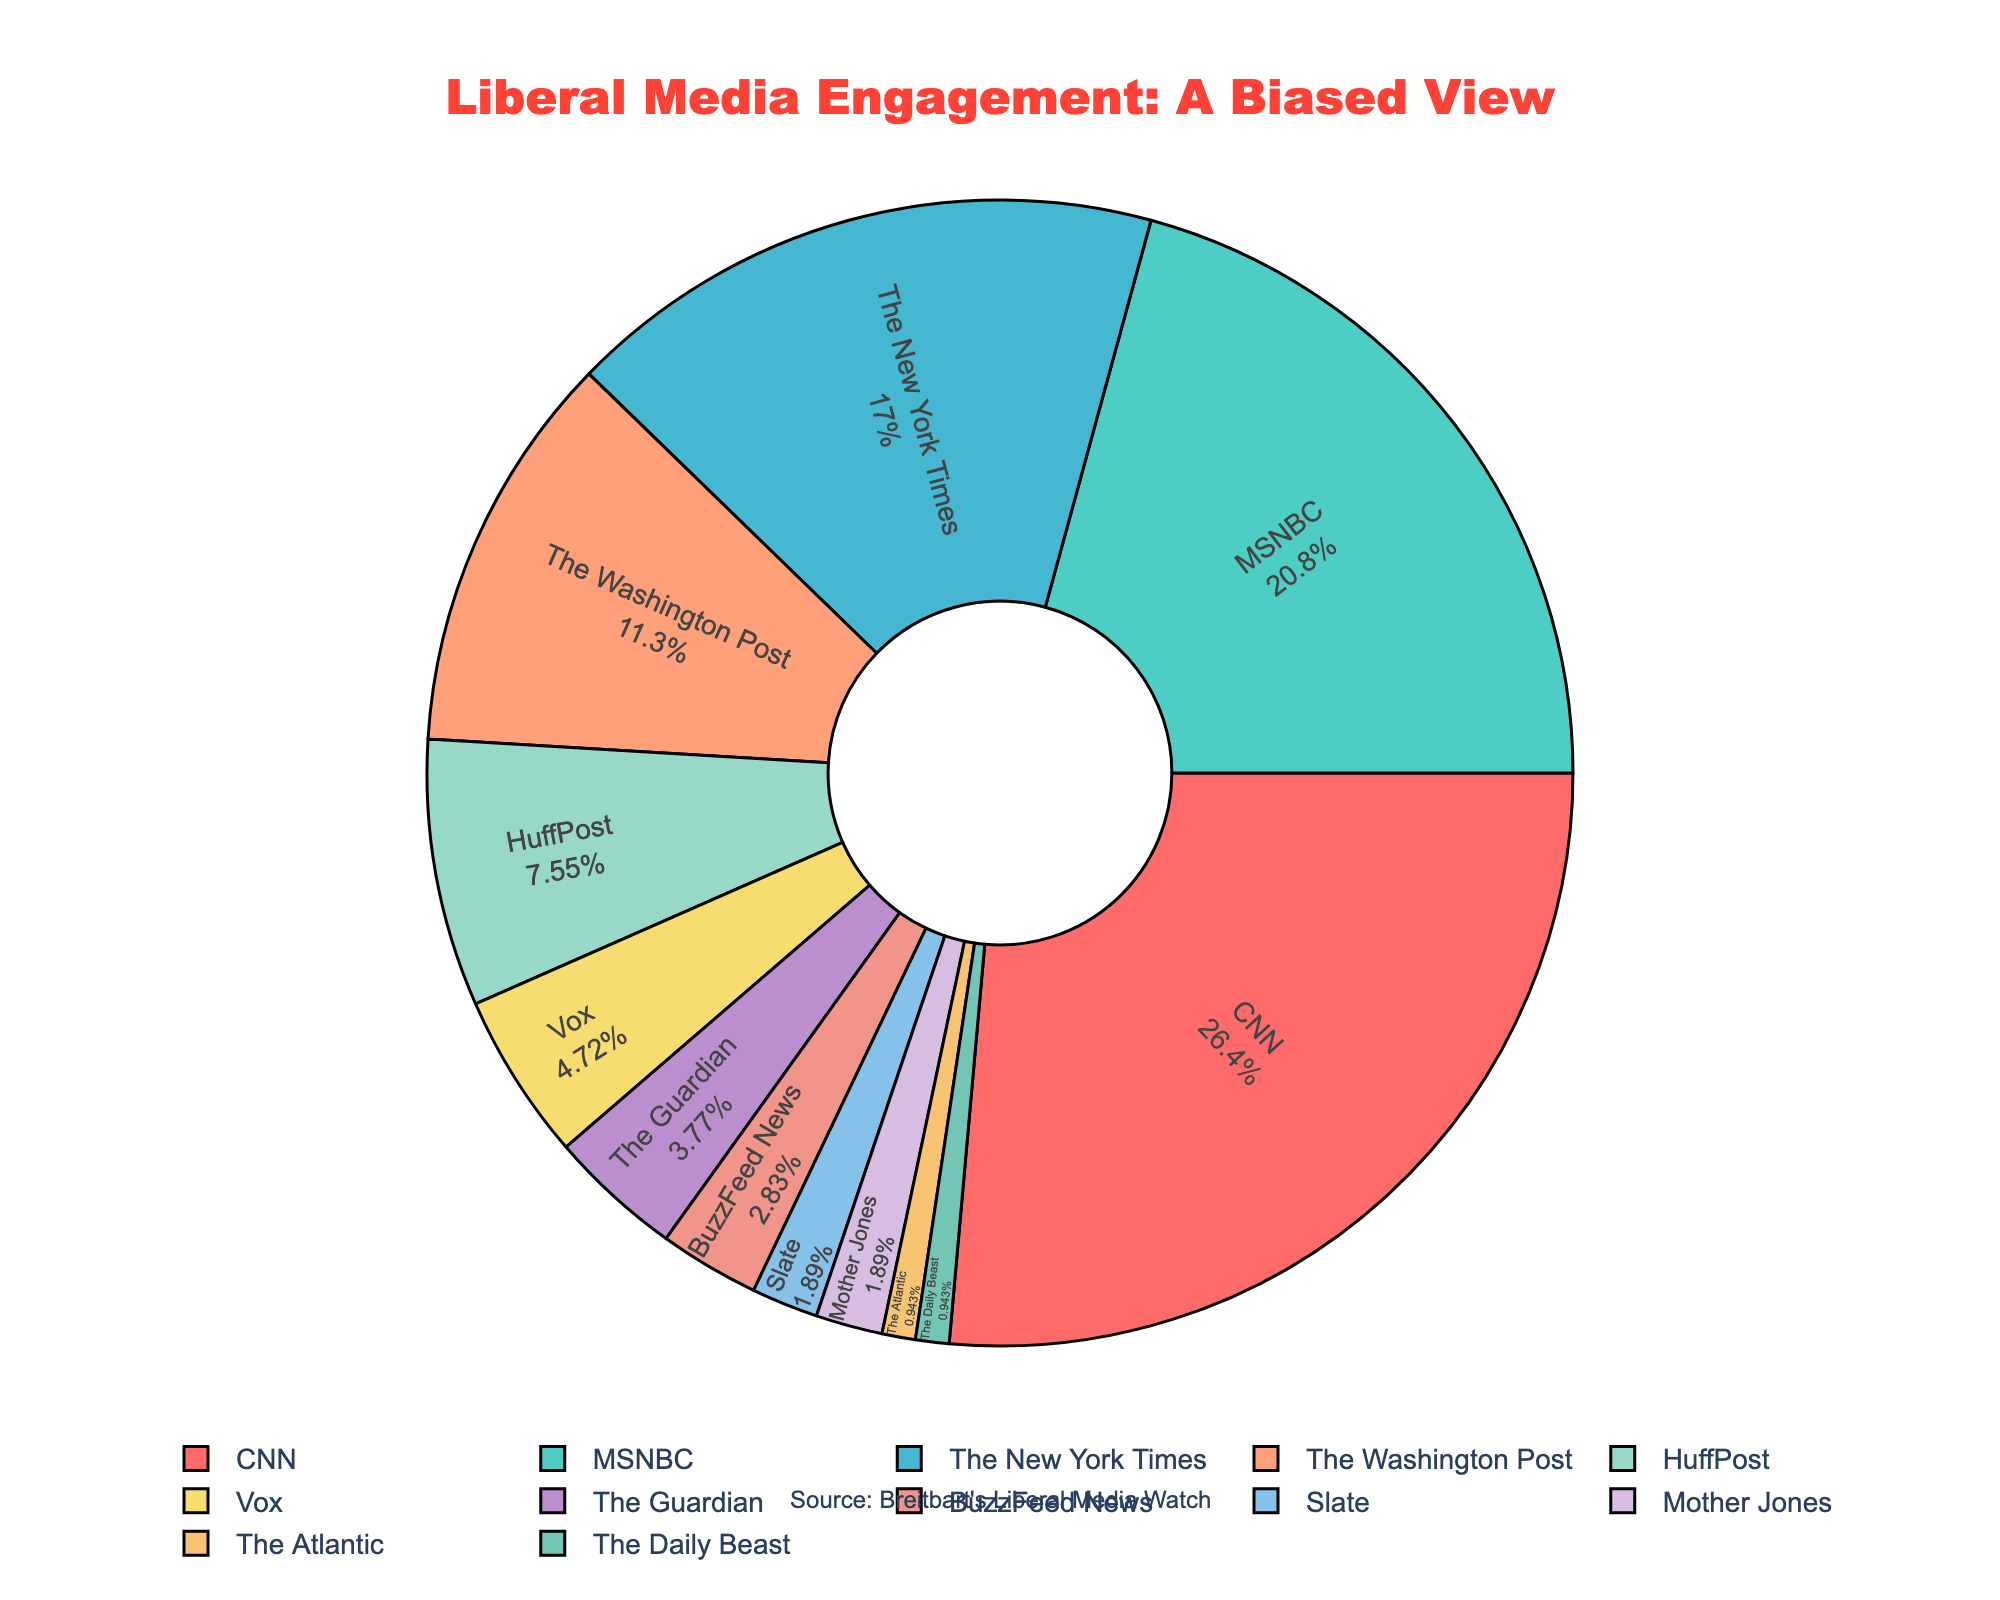Which outlet has the highest engagement percentage? From the figure, observe the segment with the largest proportion, which is labeled with both the outlet name and the percentage.
Answer: CNN Which two outlets together make up exactly 30% of the engagement? Find the two smallest percentages that sum to 30. HuffPost (8%) and Vox (5%) together is 13%. Keep adding the Guardian (4%) to get 17%, BuzzFeed News (3%) gives 20%, Slate (2%) adds up to 22%, and finally, Mother Jones (2%) gives a sum of 24%. The next segment, The Atlantic (1%) sums with The Daily Beast (1%) to equal 30.
Answer: The Atlantic and The Daily Beast What is the difference in engagement percentage between CNN and MSNBC? Identify the engagement percentages for CNN (28%) and MSNBC (22%), then calculate the difference by subtracting the smaller from the larger. 28 - 22 = 6
Answer: 6 What is the combined engagement percentage for The New York Times, The Washington Post, and HuffPost? Sum the engagement percentages of The New York Times (18%), The Washington Post (12%), and HuffPost (8%). 18 + 12 + 8 = 38
Answer: 38 Which outlet has a lower engagement percentage, Vox or The Guardian? Compare the percentages of Vox (5%) and The Guardian (4%). 4 < 5, so The Guardian has a lower percentage.
Answer: The Guardian Which outlet is represented by the red segment? Use the visual attribute of the red segment, which is the largest slice at 28% and corresponds to CNN.
Answer: CNN How many outlets have an engagement percentage less than 5%? Identify and count the segments with percentages less than 5%. The Guardian (4%), BuzzFeed News (3%), Slate (2%), Mother Jones (2%), The Atlantic (1%), and The Daily Beast (1%) add up to 6.
Answer: 6 What percentage of engagement is captured by outlets with less than 10% each? Sum the percentages of all outlets with less than 10%. HuffPost (8%), Vox (5%), The Guardian (4%), BuzzFeed News (3%), Slate (2%), Mother Jones (2%), The Atlantic (1%), The Daily Beast (1%). 8 + 5 + 4 + 3 + 2 + 2 + 1 + 1 = 26
Answer: 26 